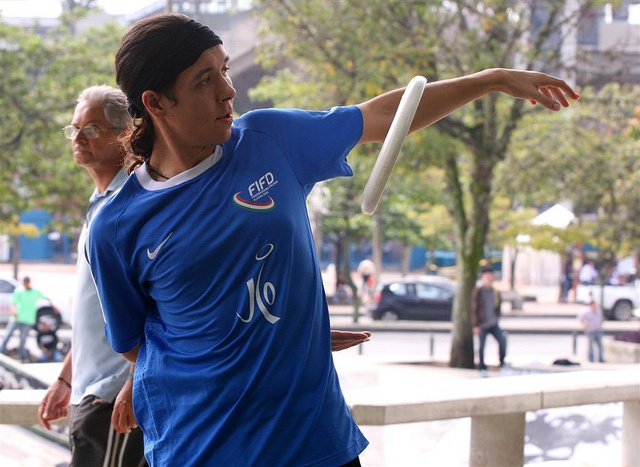Describe the objects in this image and their specific colors. I can see people in white, navy, black, blue, and maroon tones, people in white, lavender, maroon, black, and darkgray tones, car in white, gray, lavender, darkgray, and black tones, frisbee in white, darkgray, lightgray, and gray tones, and car in white, lightgray, aquamarine, darkgray, and gray tones in this image. 